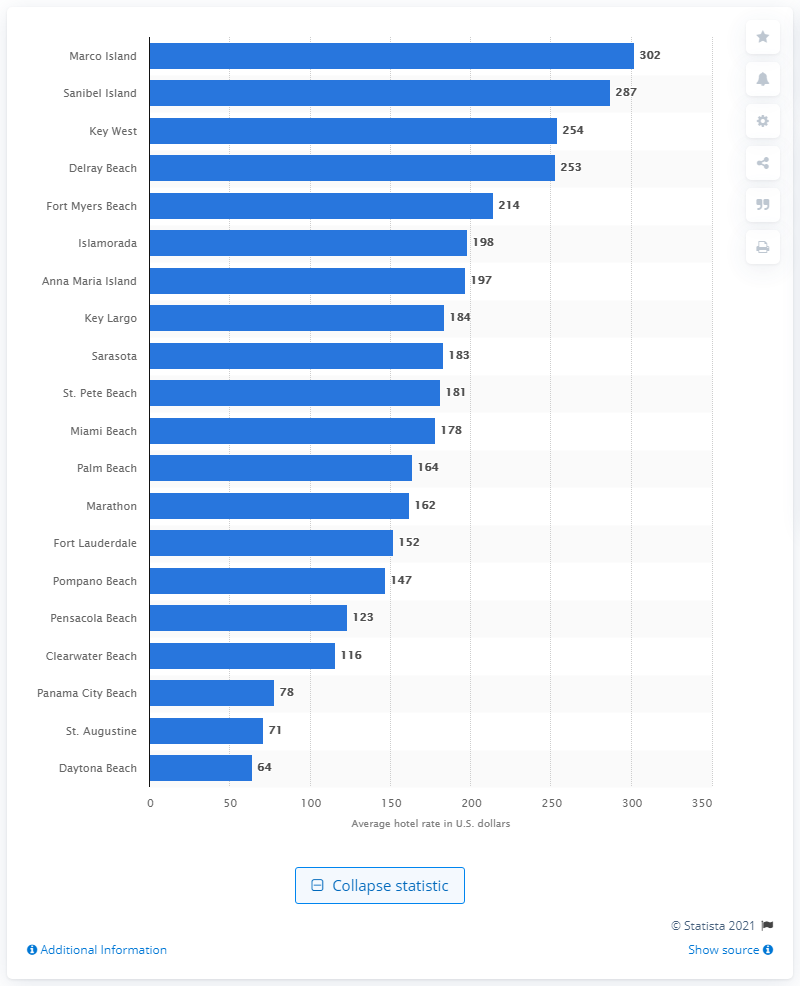Outline some significant characteristics in this image. In 2015, Marco Island was the most expensive beach destination in Florida. 